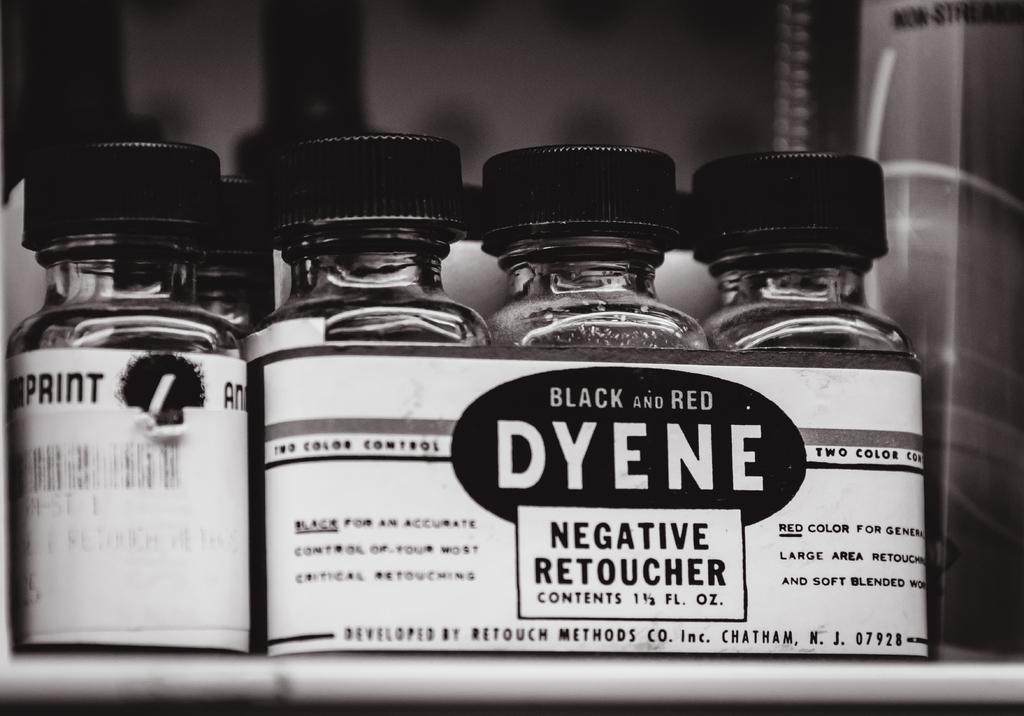<image>
Present a compact description of the photo's key features. Bottles of Black and Red Dyene, a Negative Retoucher are shown lined up on a shelf. 